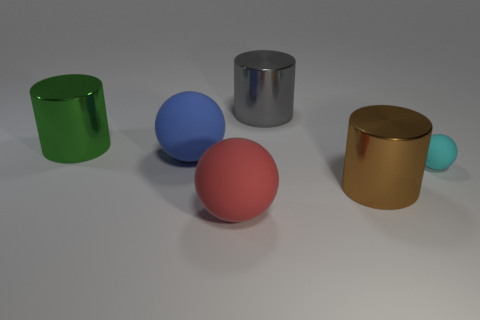Subtract all cyan matte spheres. How many spheres are left? 2 Subtract 1 cylinders. How many cylinders are left? 2 Add 3 red cubes. How many objects exist? 9 Subtract all purple matte objects. Subtract all red rubber things. How many objects are left? 5 Add 3 cyan objects. How many cyan objects are left? 4 Add 2 gray metallic cubes. How many gray metallic cubes exist? 2 Subtract 1 blue spheres. How many objects are left? 5 